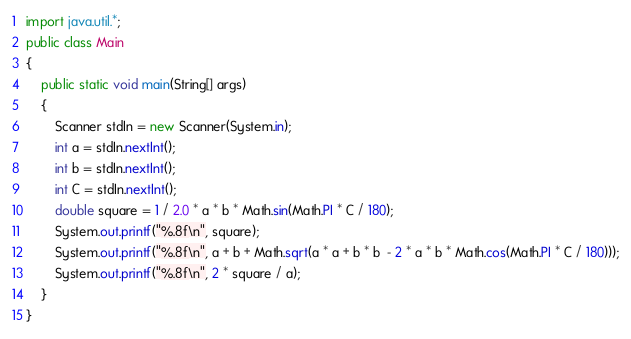<code> <loc_0><loc_0><loc_500><loc_500><_Java_>import java.util.*;
public class Main 
{
	public static void main(String[] args) 
	{
		Scanner stdIn = new Scanner(System.in);
		int a = stdIn.nextInt();
		int b = stdIn.nextInt();
		int C = stdIn.nextInt();
		double square = 1 / 2.0 * a * b * Math.sin(Math.PI * C / 180);
		System.out.printf("%.8f\n", square);
		System.out.printf("%.8f\n", a + b + Math.sqrt(a * a + b * b  - 2 * a * b * Math.cos(Math.PI * C / 180)));
		System.out.printf("%.8f\n", 2 * square / a);
	}
}</code> 